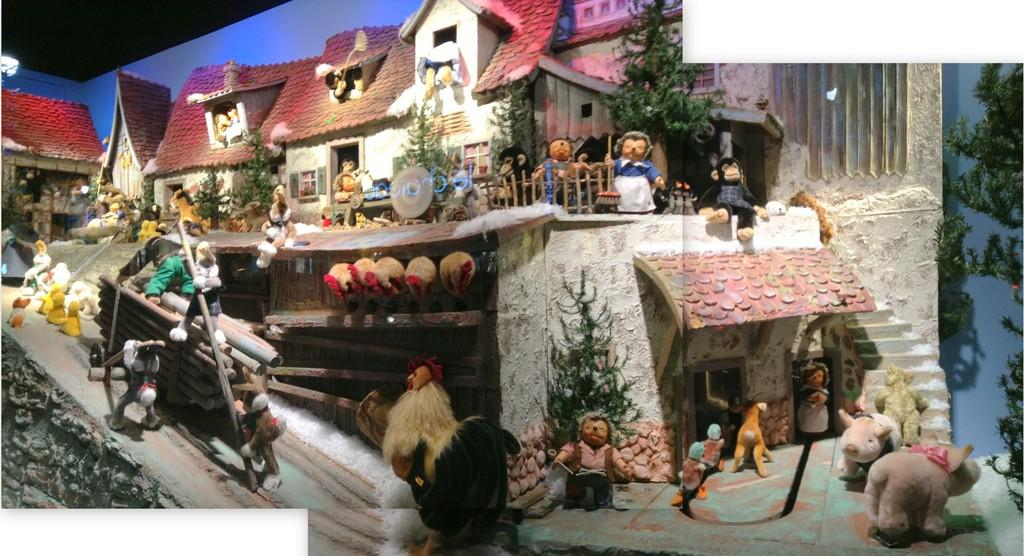What type of toys can be seen in the image? There are toy houses in the image. What other objects are present in the image? There are dolls, railings, plants, and trees in the image. Can you tell me how many pies are on the table in the image? There is no table or pies present in the image; it features toy houses, dolls, railings, plants, and trees. 